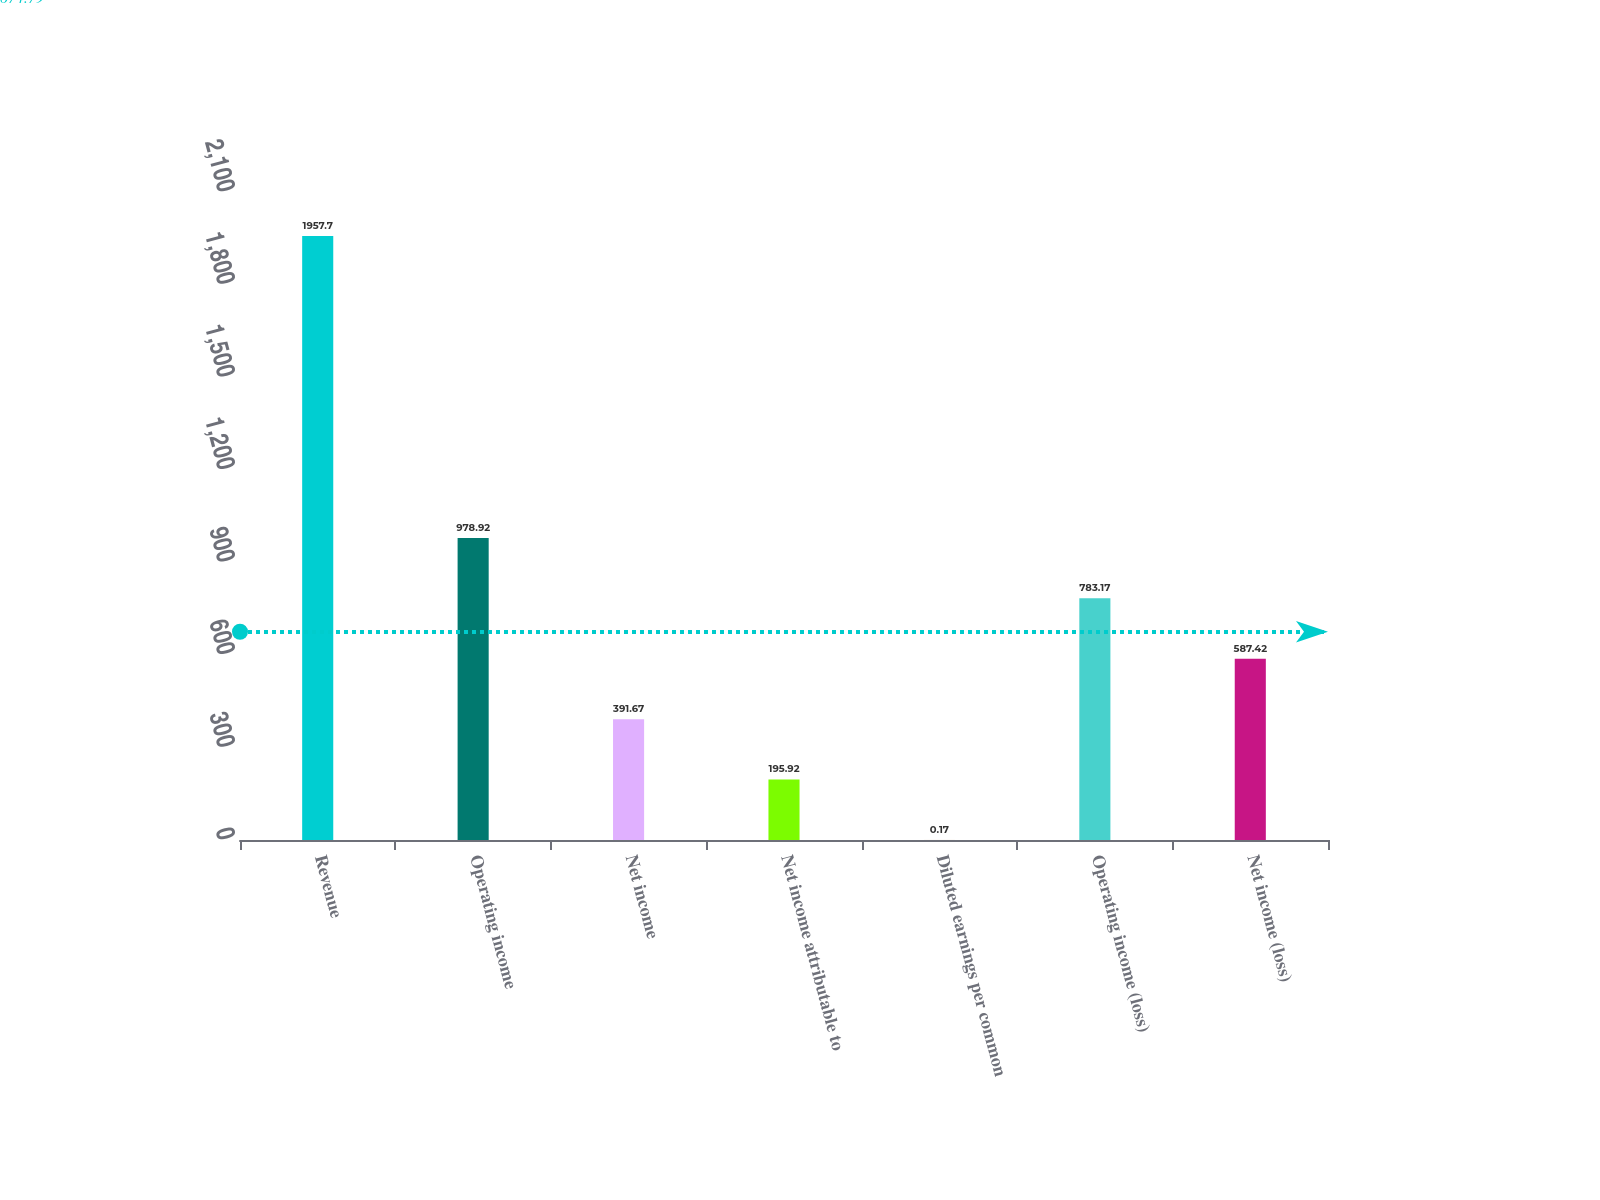Convert chart. <chart><loc_0><loc_0><loc_500><loc_500><bar_chart><fcel>Revenue<fcel>Operating income<fcel>Net income<fcel>Net income attributable to<fcel>Diluted earnings per common<fcel>Operating income (loss)<fcel>Net income (loss)<nl><fcel>1957.7<fcel>978.92<fcel>391.67<fcel>195.92<fcel>0.17<fcel>783.17<fcel>587.42<nl></chart> 